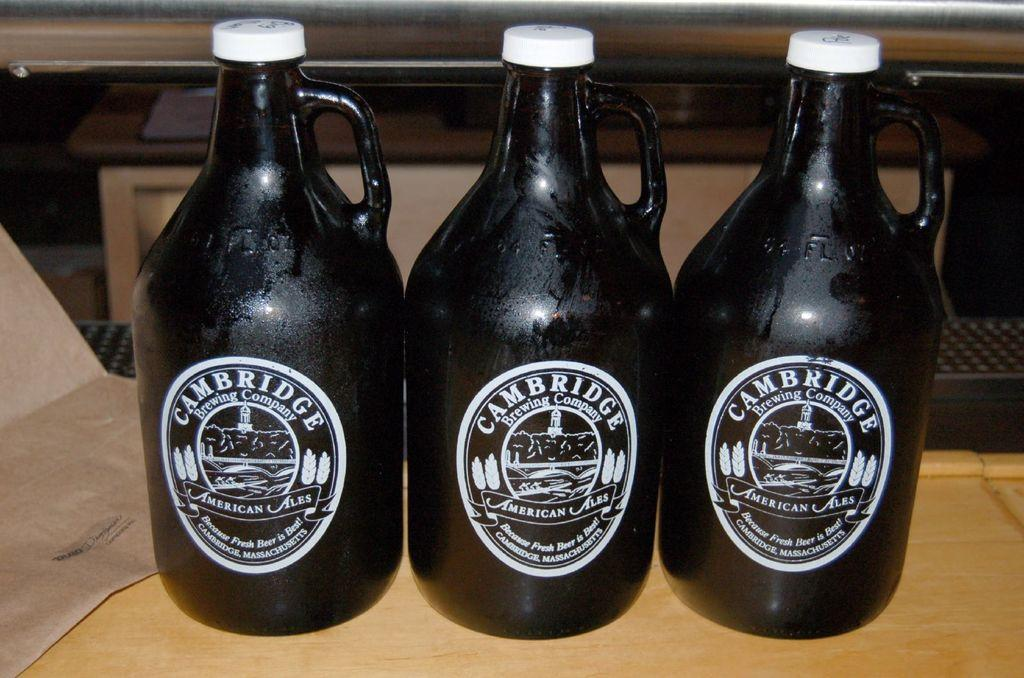<image>
Give a short and clear explanation of the subsequent image. Three bottles of American Ales from the Cambridge Brewing Company. 